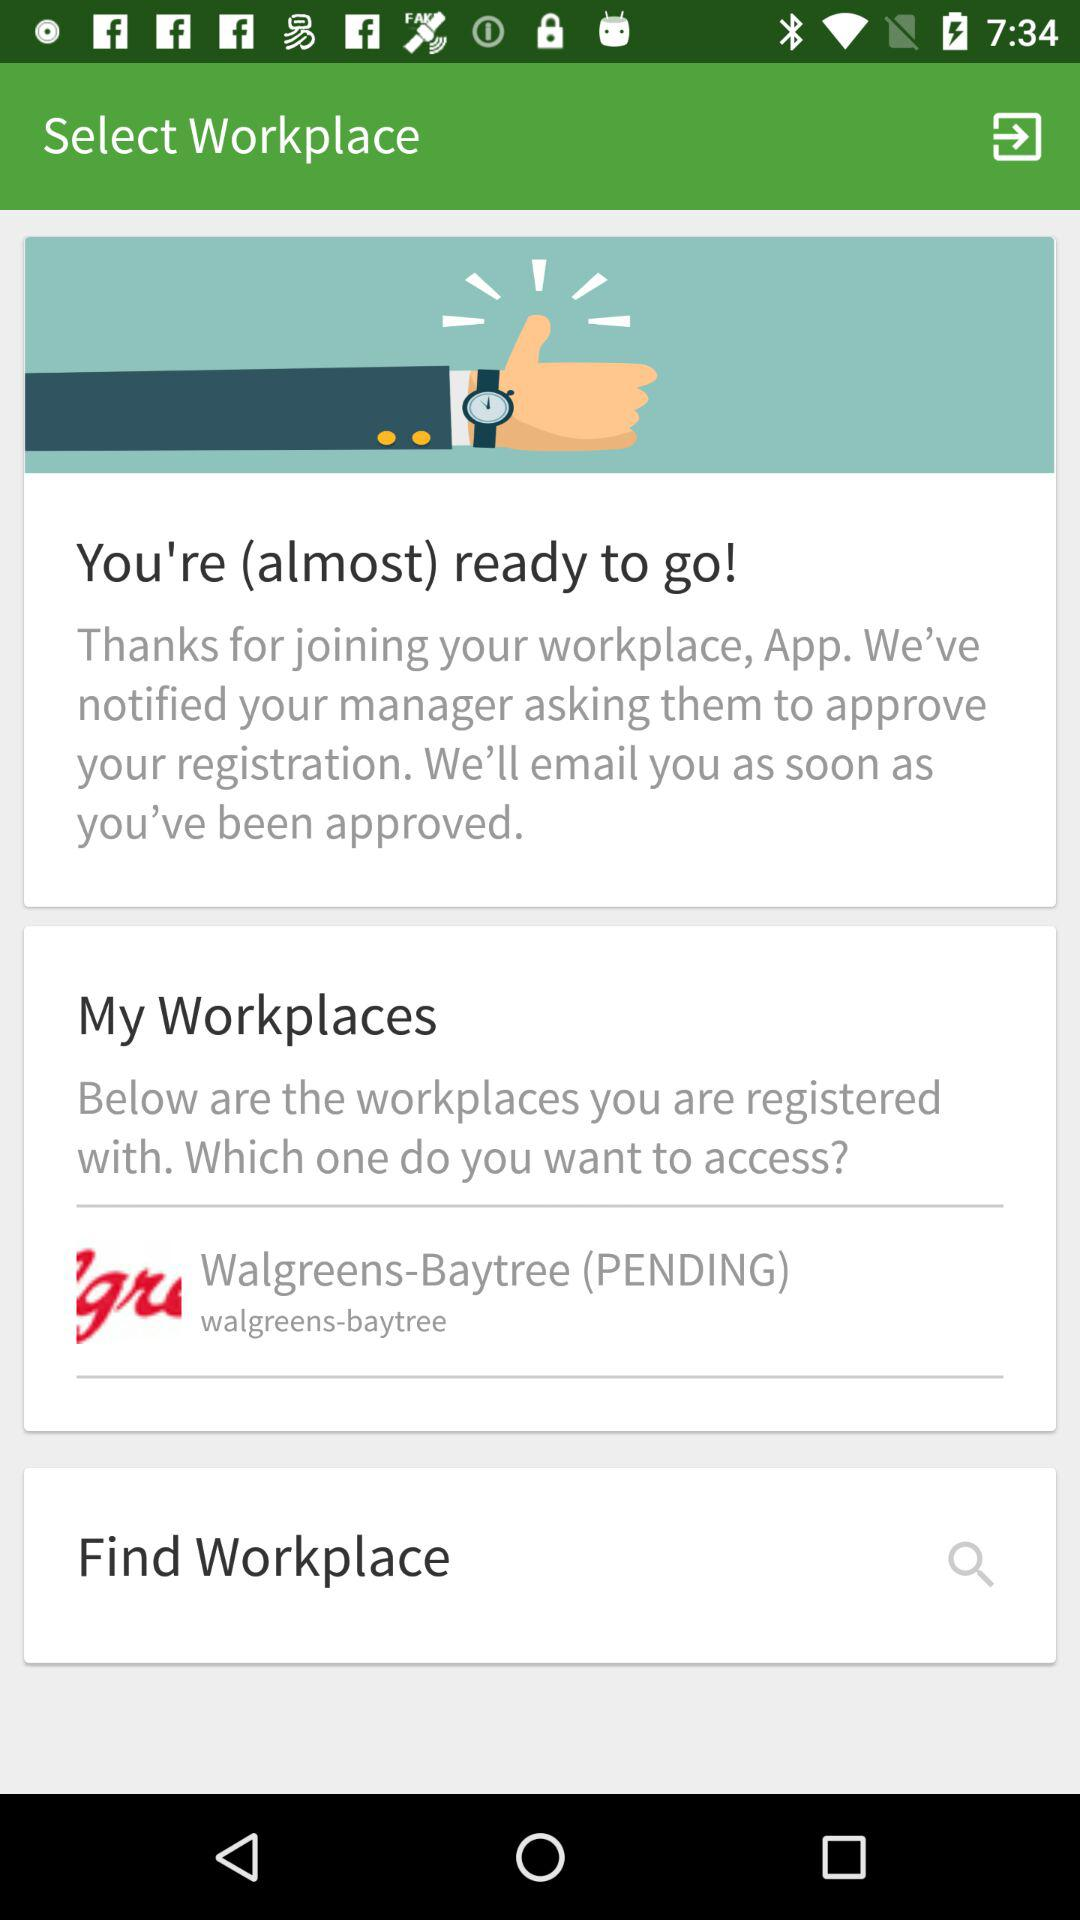Where is my work place? Your workplace is Walgreens-Baytree. 